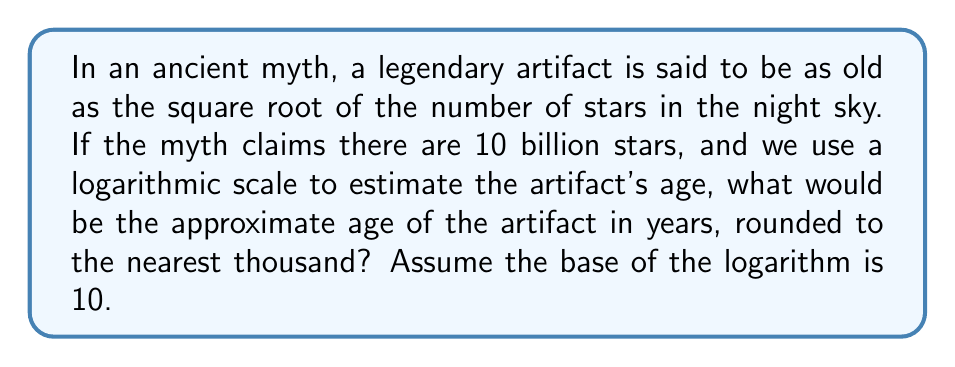Can you answer this question? Let's approach this step-by-step:

1) First, we need to calculate the square root of 10 billion stars:
   $\sqrt{10,000,000,000} = \sqrt{10^{10}} = 10^5 = 100,000$

2) Now, we need to use a logarithmic scale to estimate this age. The logarithm (base 10) of 100,000 will give us the power to which 10 must be raised to get 100,000:

   $$\log_{10}(100,000) = \log_{10}(10^5) = 5$$

3) In a logarithmic scale, each unit represents a factor of 10. So, a value of 5 on this scale would represent:

   $$10^5 = 100,000\text{ years}$$

4) Rounding to the nearest thousand:
   100,000 years rounds to 100,000 years (it's already at a thousand-year precision)

Therefore, using a logarithmic scale, the estimated age of the artifact would be approximately 100,000 years.
Answer: 100,000 years 